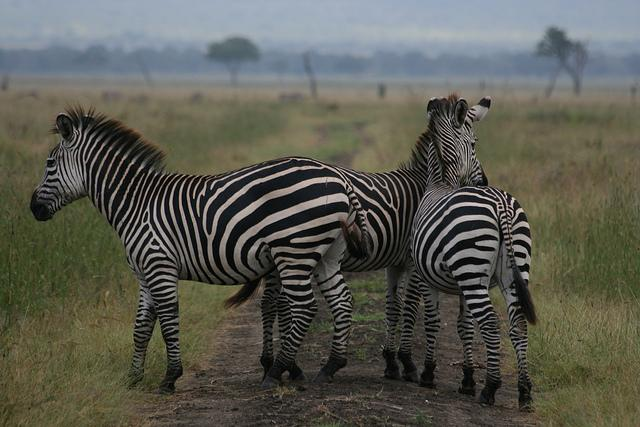How many zebras are standing in the way of the path? three 